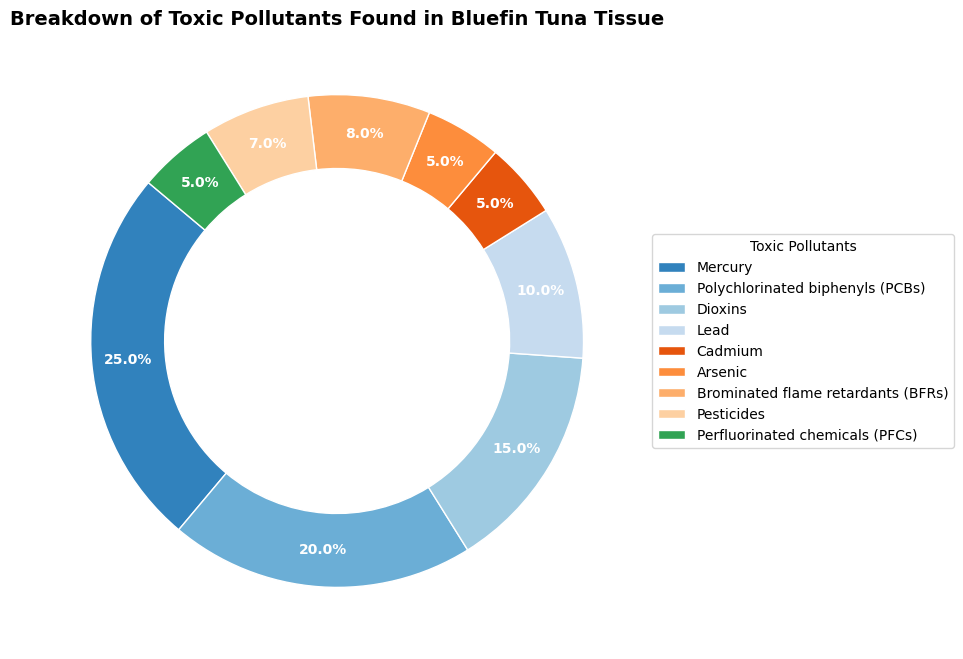Which toxic pollutant has the highest percentage? Mercury has the highest percentage as indicated by the largest segment in the ring chart.
Answer: Mercury Which toxic pollutant has a larger percentage, PCBs or Dioxins? By visual comparison, the segment for PCBs is larger than that for Dioxins. PCBs have 20% while Dioxins have 15%.
Answer: PCBs What is the combined percentage of Mercury and Lead? Mercury is 25% and Lead is 10%; their combined percentage is 25% + 10% = 35%.
Answer: 35% Are there more pollutants with percentages below or above 10%? There are six pollutants below 10% (Lead, Cadmium, Arsenic, BFRs, Pesticides, PFCs) and three above 10% (Mercury, PCBs, Dioxins). Therefore, there are more pollutants below 10%.
Answer: Below 10% What toxic pollutant is represented by the smallest segment in the ring chart? Cadmium, Arsenic, and PFCs all have the smallest segments, each occupying 5%.
Answer: Cadmium, Arsenic, PFCs Is the percentage of PCBs greater than the combined percentage of Cadmium and Arsenic? The percentage of PCBs is 20%. The combined percentage of Cadmium and Arsenic is 5% + 5% = 10%. Since 20% is greater than 10%, PCBs have a greater percentage.
Answer: Yes How much larger is the percentage of Mercury compared to BFRs? Mercury is 25% while BFRs is 8%. The difference in percentage is 25% - 8% = 17%.
Answer: 17% Compare the total percentage of PCBs, Dioxins, and Pesticides to that of Mercury and Lead. PCBs, Dioxins, and Pesticides combined are 20% + 15% + 7% = 42%. Mercury and Lead combined are 25% + 10% = 35%. 42% > 35%.
Answer: PCBs, Dioxins, and Pesticides How many toxic pollutants have a percentage of 5%? There are three toxic pollutants each with a percentage of 5%: Cadmium, Arsenic, and PFCs.
Answer: 3 Which color represents BFRs in the ring chart? By observing the color segments in the graph, BFRs can be identified by locating the segment labeled with 8%.
Answer: [Color accessible in the actual image, typically a form of green or blue] 